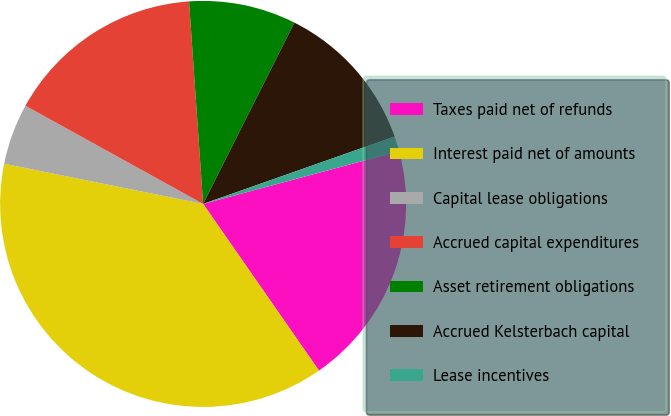<chart> <loc_0><loc_0><loc_500><loc_500><pie_chart><fcel>Taxes paid net of refunds<fcel>Interest paid net of amounts<fcel>Capital lease obligations<fcel>Accrued capital expenditures<fcel>Asset retirement obligations<fcel>Accrued Kelsterbach capital<fcel>Lease incentives<nl><fcel>19.52%<fcel>37.84%<fcel>4.86%<fcel>15.86%<fcel>8.53%<fcel>12.19%<fcel>1.2%<nl></chart> 